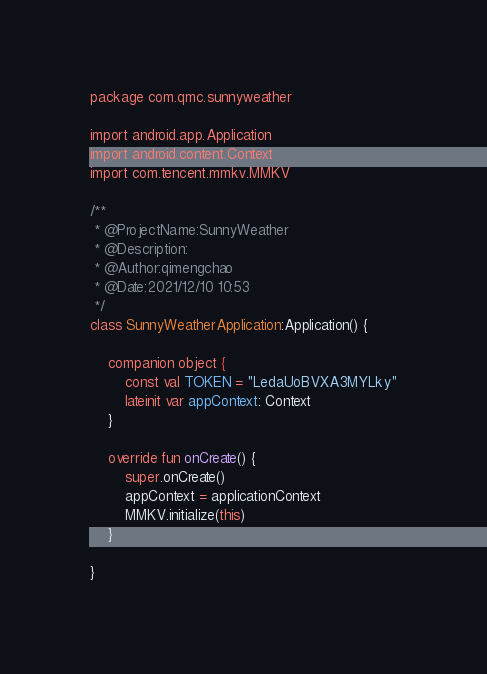Convert code to text. <code><loc_0><loc_0><loc_500><loc_500><_Kotlin_>package com.qmc.sunnyweather

import android.app.Application
import android.content.Context
import com.tencent.mmkv.MMKV

/**
 * @ProjectName:SunnyWeather
 * @Description:
 * @Author:qimengchao
 * @Date:2021/12/10 10:53
 */
class SunnyWeatherApplication:Application() {

    companion object {
        const val TOKEN = "LedaUoBVXA3MYLky"
        lateinit var appContext: Context
    }

    override fun onCreate() {
        super.onCreate()
        appContext = applicationContext
        MMKV.initialize(this)
    }

}</code> 